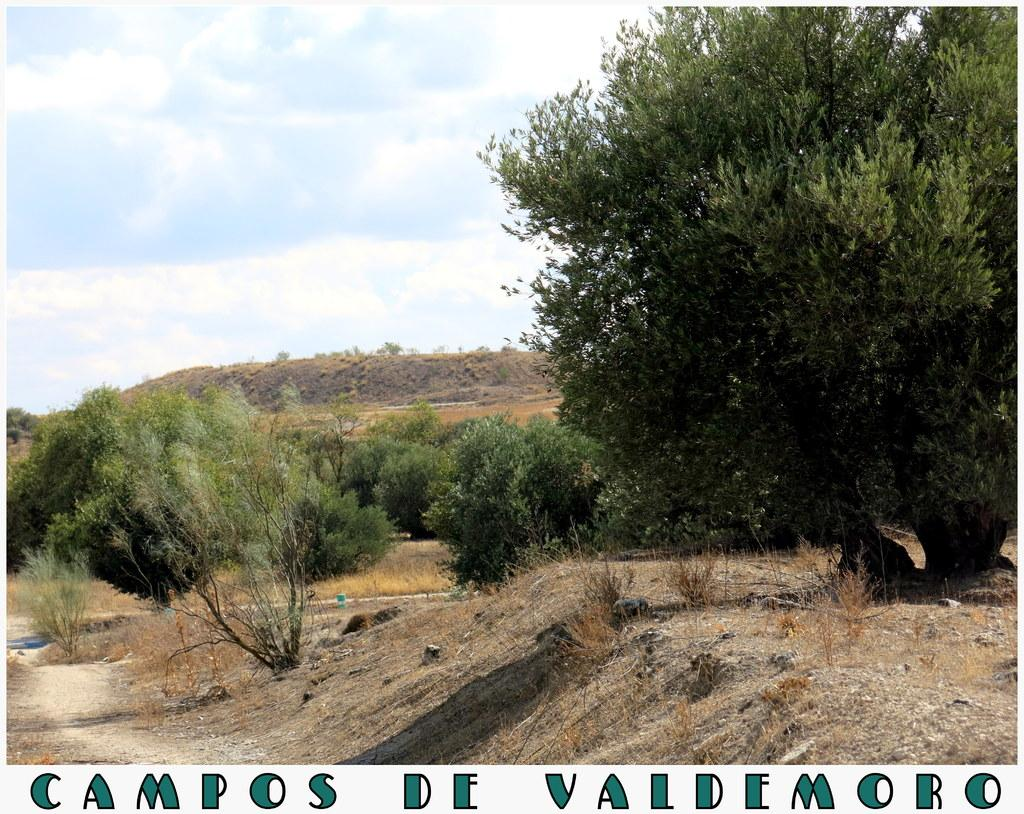What type of vegetation can be seen in the image? There are trees in the image. What is on the ground in the image? There are stones on the ground in the image. What can be seen in the background of the image? The sky is visible in the background of the image. What is present in the sky? Clouds are present in the sky. What is written or displayed at the bottom of the image? There is some text at the bottom of the image. Can you describe the girl playing with the beast in the image? There is no girl or beast present in the image. What type of pleasure can be seen in the image? The image does not depict any specific pleasure or emotion; it features trees, stones, the sky, clouds, and text. 